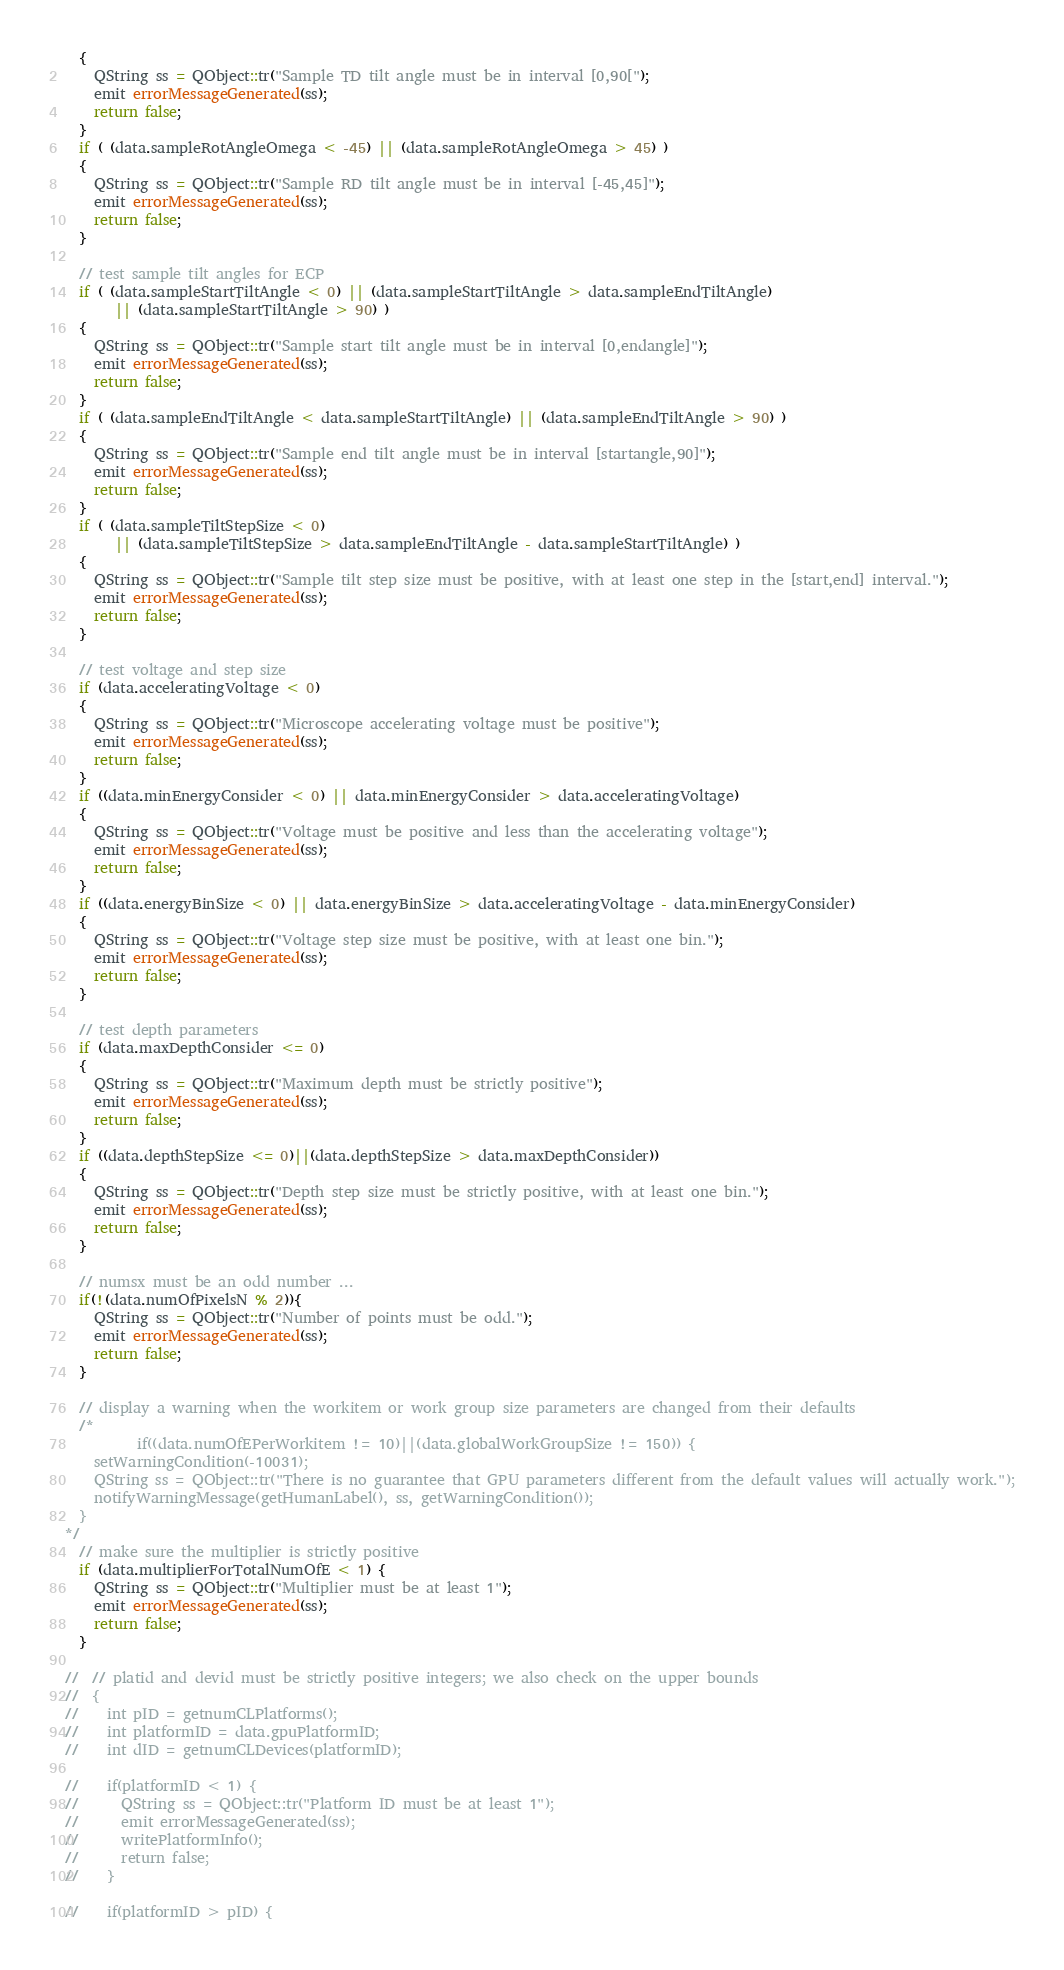Convert code to text. <code><loc_0><loc_0><loc_500><loc_500><_C++_>  {
    QString ss = QObject::tr("Sample TD tilt angle must be in interval [0,90[");
    emit errorMessageGenerated(ss);
    return false;
  }
  if ( (data.sampleRotAngleOmega < -45) || (data.sampleRotAngleOmega > 45) )
  {
    QString ss = QObject::tr("Sample RD tilt angle must be in interval [-45,45]");
    emit errorMessageGenerated(ss);
    return false;
  }

  // test sample tilt angles for ECP
  if ( (data.sampleStartTiltAngle < 0) || (data.sampleStartTiltAngle > data.sampleEndTiltAngle)
       || (data.sampleStartTiltAngle > 90) )
  {
    QString ss = QObject::tr("Sample start tilt angle must be in interval [0,endangle]");
    emit errorMessageGenerated(ss);
    return false;
  }
  if ( (data.sampleEndTiltAngle < data.sampleStartTiltAngle) || (data.sampleEndTiltAngle > 90) )
  {
    QString ss = QObject::tr("Sample end tilt angle must be in interval [startangle,90]");
    emit errorMessageGenerated(ss);
    return false;
  }
  if ( (data.sampleTiltStepSize < 0)
       || (data.sampleTiltStepSize > data.sampleEndTiltAngle - data.sampleStartTiltAngle) )
  {
    QString ss = QObject::tr("Sample tilt step size must be positive, with at least one step in the [start,end] interval.");
    emit errorMessageGenerated(ss);
    return false;
  }

  // test voltage and step size
  if (data.acceleratingVoltage < 0)
  {
    QString ss = QObject::tr("Microscope accelerating voltage must be positive");
    emit errorMessageGenerated(ss);
    return false;
  }
  if ((data.minEnergyConsider < 0) || data.minEnergyConsider > data.acceleratingVoltage)
  {
    QString ss = QObject::tr("Voltage must be positive and less than the accelerating voltage");
    emit errorMessageGenerated(ss);
    return false;
  }
  if ((data.energyBinSize < 0) || data.energyBinSize > data.acceleratingVoltage - data.minEnergyConsider)
  {
    QString ss = QObject::tr("Voltage step size must be positive, with at least one bin.");
    emit errorMessageGenerated(ss);
    return false;
  }

  // test depth parameters
  if (data.maxDepthConsider <= 0)
  {
    QString ss = QObject::tr("Maximum depth must be strictly positive");
    emit errorMessageGenerated(ss);
    return false;
  }
  if ((data.depthStepSize <= 0)||(data.depthStepSize > data.maxDepthConsider))
  {
    QString ss = QObject::tr("Depth step size must be strictly positive, with at least one bin.");
    emit errorMessageGenerated(ss);
    return false;
  }

  // numsx must be an odd number ...
  if(!(data.numOfPixelsN % 2)){
    QString ss = QObject::tr("Number of points must be odd.");
    emit errorMessageGenerated(ss);
    return false;
  }

  // display a warning when the workitem or work group size parameters are changed from their defaults
  /*
          if((data.numOfEPerWorkitem != 10)||(data.globalWorkGroupSize != 150)) {
    setWarningCondition(-10031);
    QString ss = QObject::tr("There is no guarantee that GPU parameters different from the default values will actually work.");
    notifyWarningMessage(getHumanLabel(), ss, getWarningCondition());
  }
*/
  // make sure the multiplier is strictly positive
  if (data.multiplierForTotalNumOfE < 1) {
    QString ss = QObject::tr("Multiplier must be at least 1");
    emit errorMessageGenerated(ss);
    return false;
  }

//  // platid and devid must be strictly positive integers; we also check on the upper bounds
//  {
//    int pID = getnumCLPlatforms();
//    int platformID = data.gpuPlatformID;
//    int dID = getnumCLDevices(platformID);

//    if(platformID < 1) {
//      QString ss = QObject::tr("Platform ID must be at least 1");
//      emit errorMessageGenerated(ss);
//      writePlatformInfo();
//      return false;
//    }

//    if(platformID > pID) {</code> 